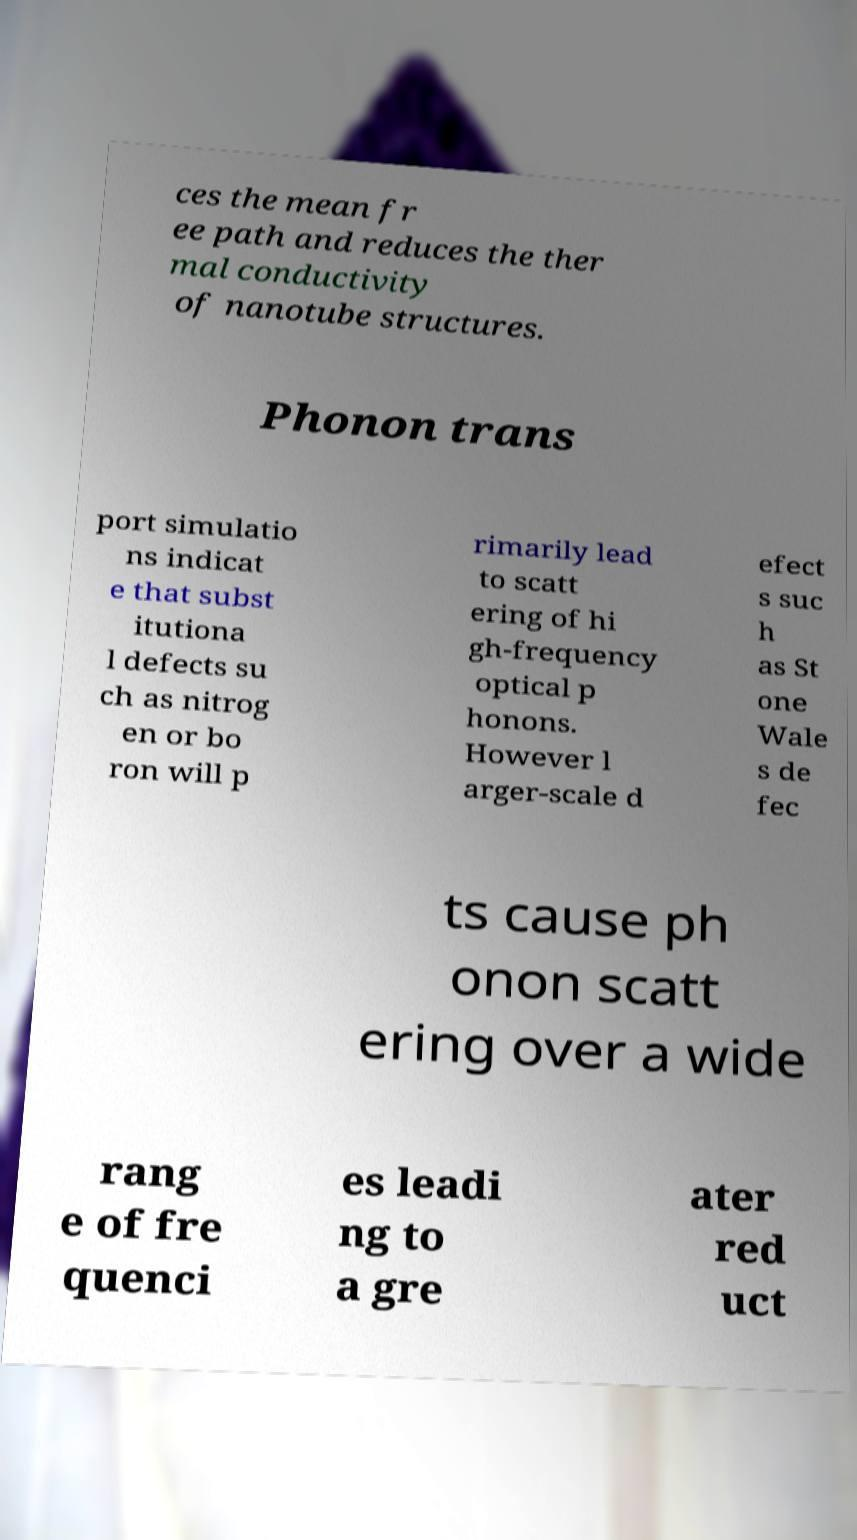Please identify and transcribe the text found in this image. ces the mean fr ee path and reduces the ther mal conductivity of nanotube structures. Phonon trans port simulatio ns indicat e that subst itutiona l defects su ch as nitrog en or bo ron will p rimarily lead to scatt ering of hi gh-frequency optical p honons. However l arger-scale d efect s suc h as St one Wale s de fec ts cause ph onon scatt ering over a wide rang e of fre quenci es leadi ng to a gre ater red uct 